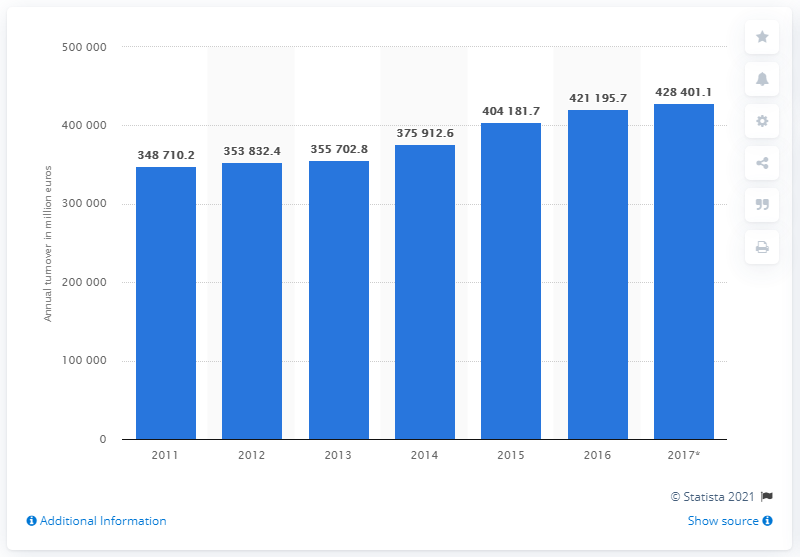Identify some key points in this picture. In 2017, the turnover of the food and beverage service activities industry in the European Union was 428,401.1 million euros. 